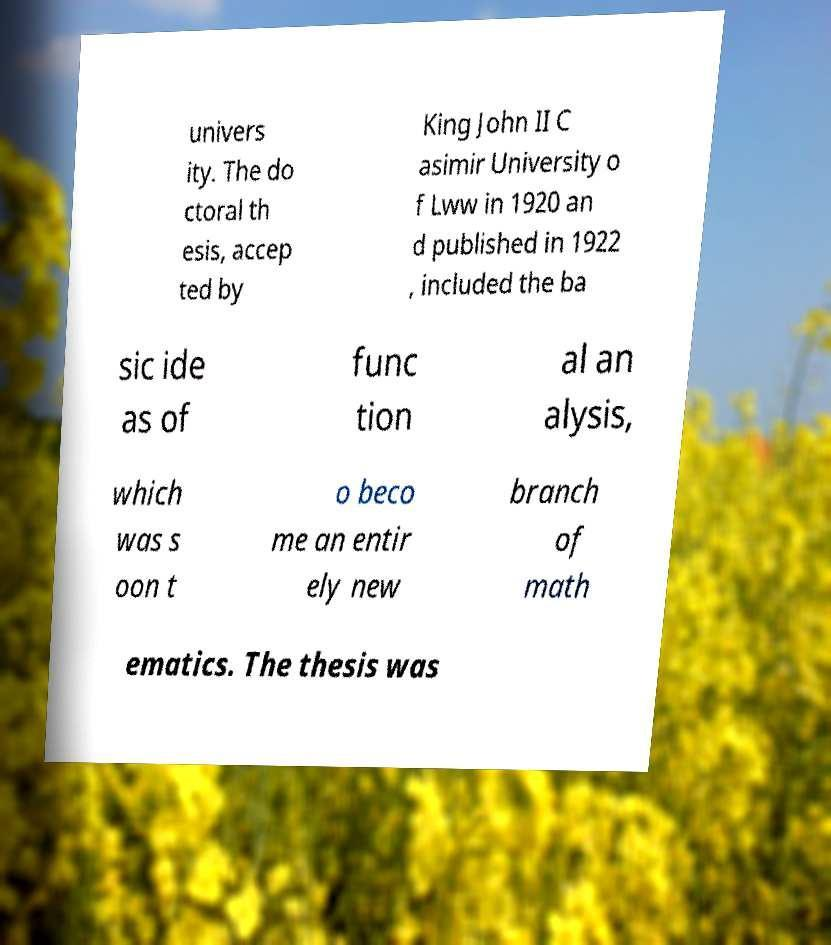There's text embedded in this image that I need extracted. Can you transcribe it verbatim? univers ity. The do ctoral th esis, accep ted by King John II C asimir University o f Lww in 1920 an d published in 1922 , included the ba sic ide as of func tion al an alysis, which was s oon t o beco me an entir ely new branch of math ematics. The thesis was 